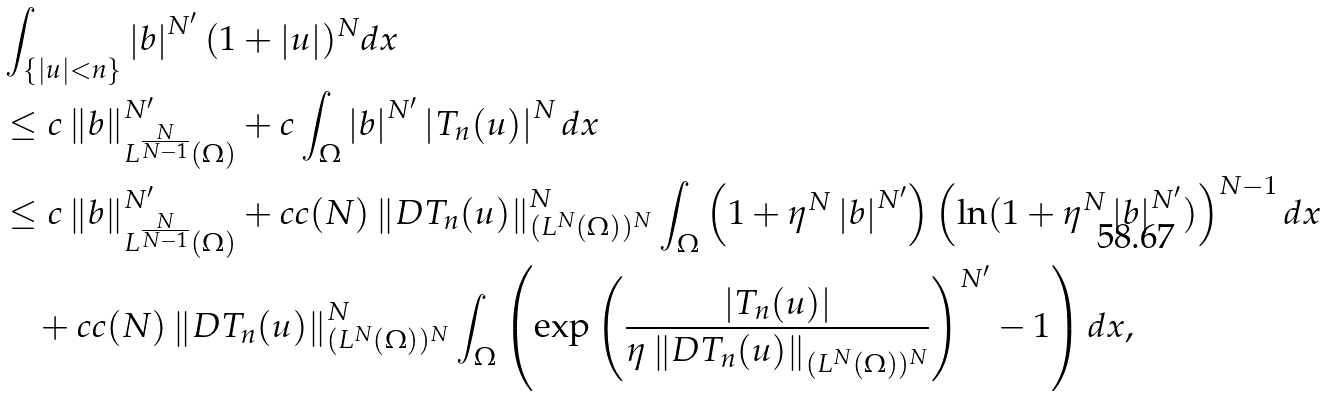Convert formula to latex. <formula><loc_0><loc_0><loc_500><loc_500>\null & \int _ { \left \{ \left | u \right | < n \right \} } \left | b \right | ^ { N ^ { \prime } } ( 1 + \left | u \right | ) ^ { N } d x \\ & \leq c \left \| b \right \| _ { L ^ { \frac { N } { N - 1 } } ( \Omega ) } ^ { N ^ { \prime } } + c \int _ { \Omega } \left | b \right | ^ { N ^ { \prime } } \left | T _ { n } ( u ) \right | ^ { N } d x \\ & \leq c \left \| b \right \| _ { L ^ { \frac { N } { N - 1 } } ( \Omega ) } ^ { N ^ { \prime } } + c c { ( N ) } \left \| D T _ { n } ( u ) \right \| _ { ( L ^ { N } ( \Omega ) ) ^ { N } } ^ { N } \int _ { \Omega } \left ( 1 + \eta ^ { N } \left | b \right | ^ { N ^ { \prime } } \right ) \left ( \ln ( 1 + \eta ^ { N } \left | b \right | ^ { N ^ { \prime } } ) \right ) ^ { N - 1 } d x \\ & \quad + c c { ( N ) } \left \| D T _ { n } ( u ) \right \| _ { ( L ^ { N } ( \Omega ) ) ^ { N } } ^ { N } \int _ { \Omega } \left ( \exp \left ( \frac { \left | T _ { n } ( u ) \right | } { \eta \left \| D T _ { n } ( u ) \right \| _ { ( L ^ { N } ( \Omega ) ) ^ { N } } } \right ) ^ { N ^ { \prime } } - 1 \right ) d x ,</formula> 